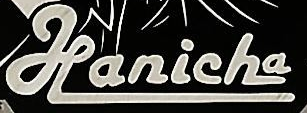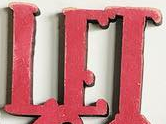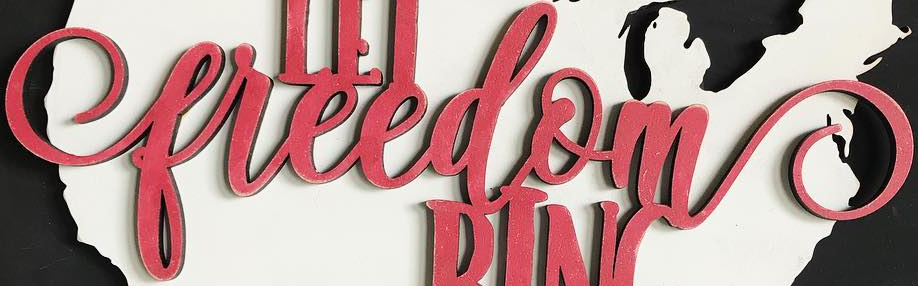Identify the words shown in these images in order, separated by a semicolon. Hanicha; LET; freedom 